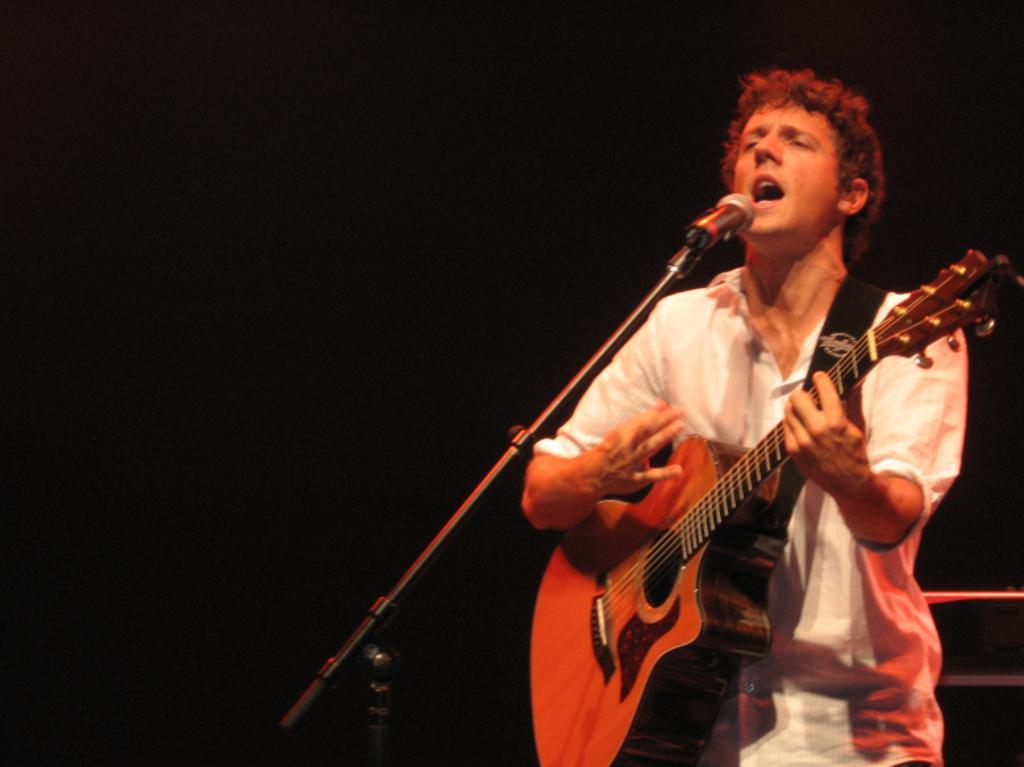How would you summarize this image in a sentence or two? Here we can see a man who is singing on the mike. And he is playing guitar. 